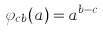Convert formula to latex. <formula><loc_0><loc_0><loc_500><loc_500>\varphi _ { c b } ( a ) = a ^ { b - c }</formula> 